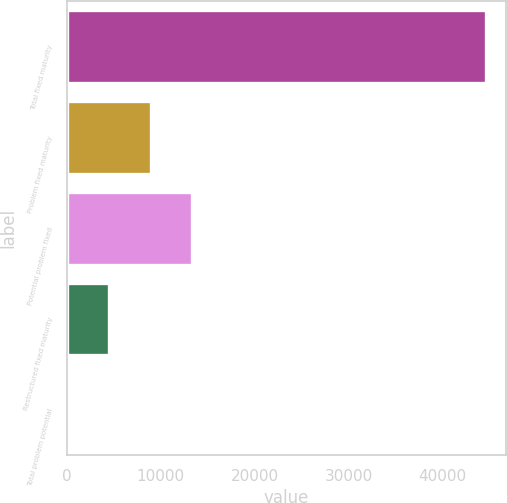Convert chart to OTSL. <chart><loc_0><loc_0><loc_500><loc_500><bar_chart><fcel>Total fixed maturity<fcel>Problem fixed maturity<fcel>Potential problem fixed<fcel>Restructured fixed maturity<fcel>Total problem potential<nl><fcel>44548.7<fcel>8909.83<fcel>13364.7<fcel>4454.97<fcel>0.11<nl></chart> 